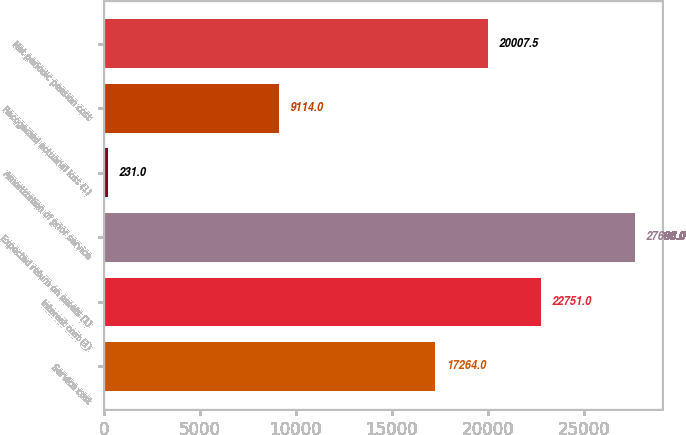Convert chart to OTSL. <chart><loc_0><loc_0><loc_500><loc_500><bar_chart><fcel>Service cost<fcel>Interest cost (1)<fcel>Expected return on assets (1)<fcel>Amortization of prior service<fcel>Recognized actuarial loss (1)<fcel>Net periodic pension cost<nl><fcel>17264<fcel>22751<fcel>27666<fcel>231<fcel>9114<fcel>20007.5<nl></chart> 